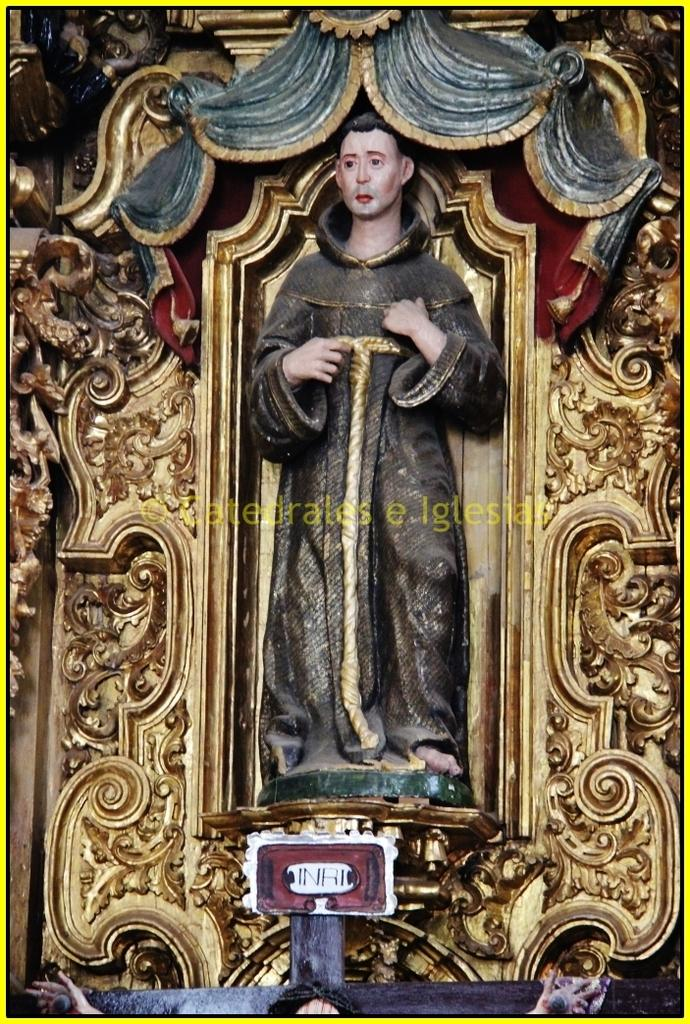What type of object is depicted in the image? There is a cartoon statue of a human in the image. How is the statue positioned? The statue is standing. What can be seen on the wall in the image? There are decorative designs on the wall. What color is the wall in the image? The wall is golden in color. What type of nut is used to secure the statue to the wall in the image? There is no nut visible in the image, and the statue is not attached to the wall. 